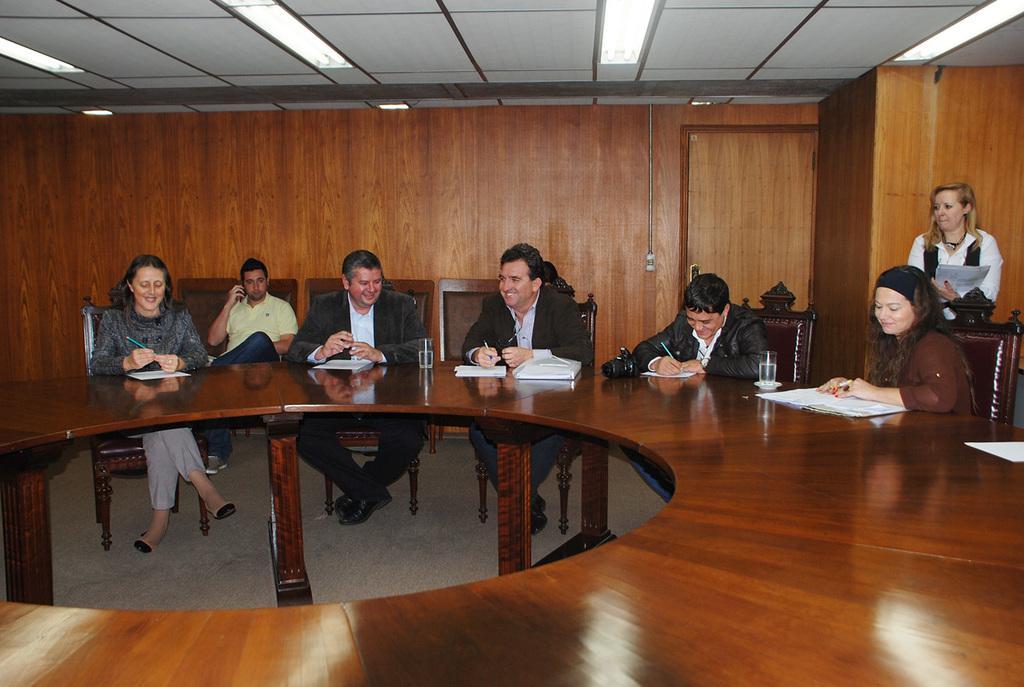How would you summarize this image in a sentence or two? This picture shows a group of people seated on the chairs and we see some books and glasses on the table and we see a woman Standing and holding papers in her hand and a man seated and speaking on the mobile 